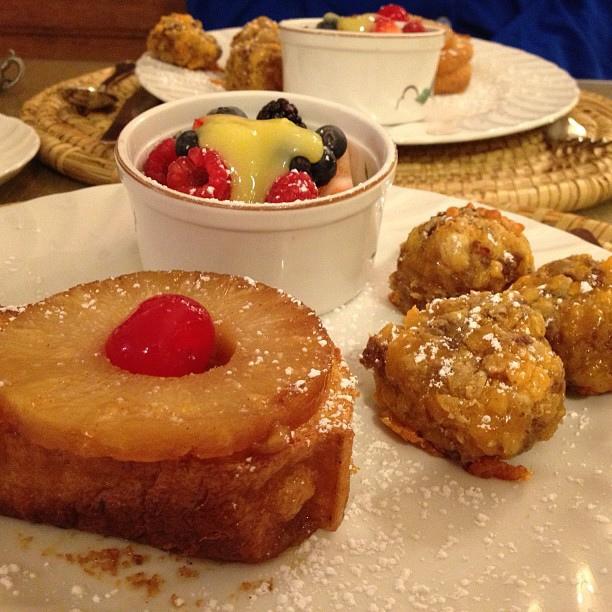What color are the plates?
Be succinct. White. What kind of dessert is on the plate?
Short answer required. Cake and fruit. Is this meal vegetarian friendly?
Be succinct. Yes. How many desserts are in this scene?
Keep it brief. 3. What food is on the plate?
Keep it brief. Dessert. 